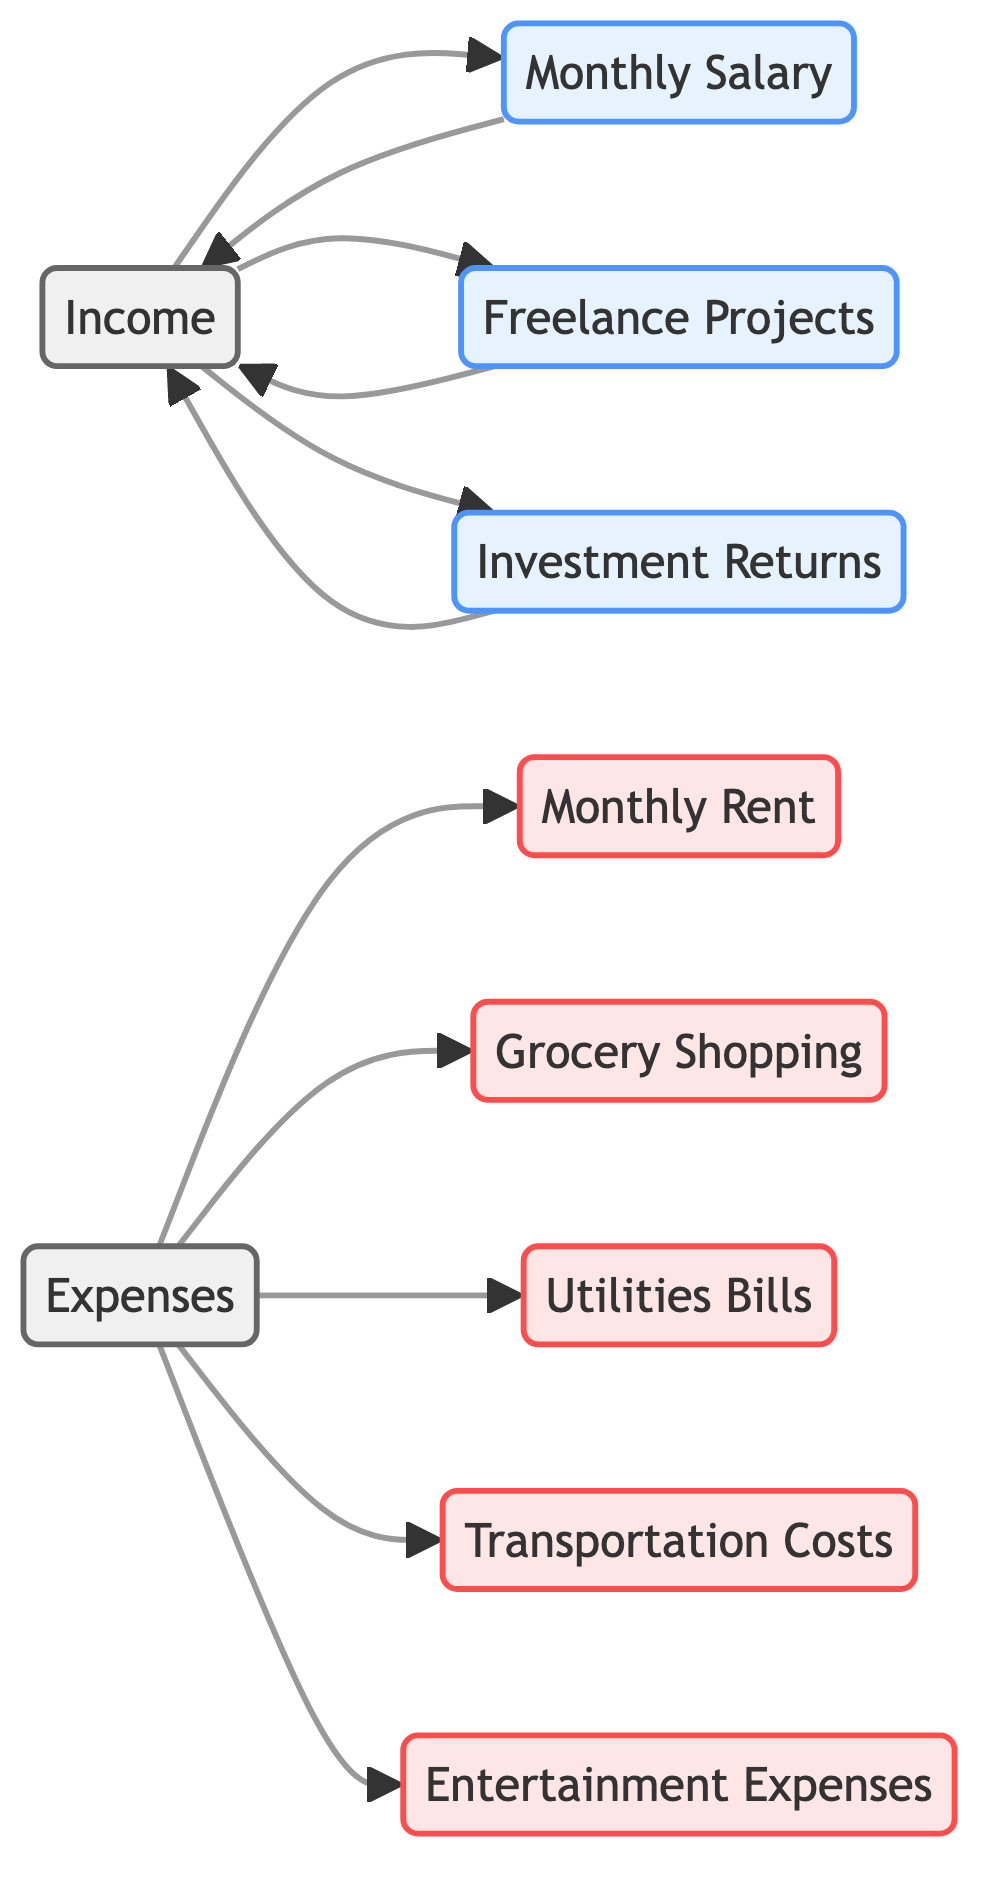What's the total number of nodes in the diagram? The diagram contains a total of 10 nodes, which are: Income, Monthly Salary, Freelance Projects, Investment Returns, Expenses, Monthly Rent, Grocery Shopping, Utilities Bills, Transportation Costs, and Entertainment Expenses.
Answer: 10 How many edges connect the Income node? The Income node has three outgoing edges connecting it to Monthly Salary, Freelance Projects, and Investment Returns. Therefore, there are three edges connecting from Income.
Answer: 3 What is the label of the node that represents Rent? The node that represents Rent is labeled as "Monthly Rent" in the diagram.
Answer: Monthly Rent Which node has the most outgoing edges? The Income node has three outgoing edges to Salary, Freelance, and Investments, which is more than any other node.
Answer: Income How are Freelance Projects and Investment Returns related? Both Freelance Projects and Investment Returns are directly connected to the Income node, indicating they are both sources of income.
Answer: Connected to Income What is the relationship of Utilities to Expenses? Utilities is one of the specific types of expenses under the Expenses category, with an outgoing edge from Expenses to Utilities.
Answer: Specific expense How many edges lead to the Expenses node? The Expenses node has five incoming edges from the sub-category expenses: Monthly Rent, Grocery Shopping, Utilities Bills, Transportation Costs, and Entertainment Expenses. Therefore, there are five edges leading to Expenses.
Answer: 5 Which nodes are directly connected to the Expense category? The nodes directly connected to the Expenses category are Monthly Rent, Grocery Shopping, Utilities Bills, Transportation Costs, and Entertainment Expenses.
Answer: 5 nodes Is there a direct connection from any expense node back to Income? No, there is no direct connection from any of the expense nodes back to the Income node, as represented by the edges in the diagram.
Answer: No 